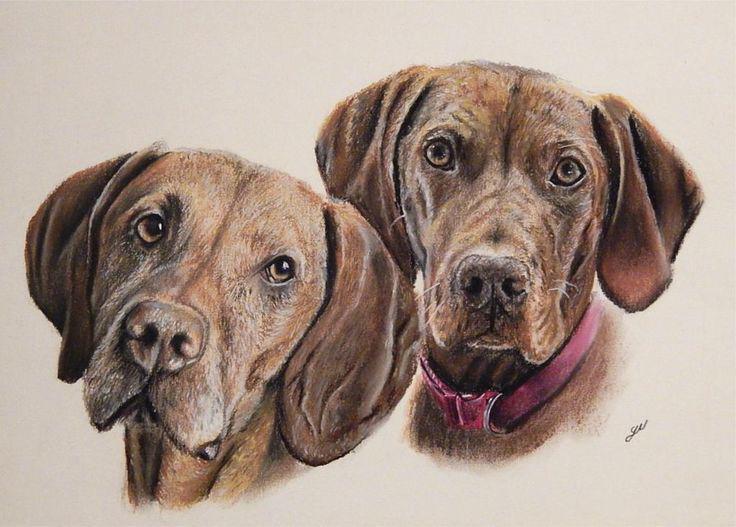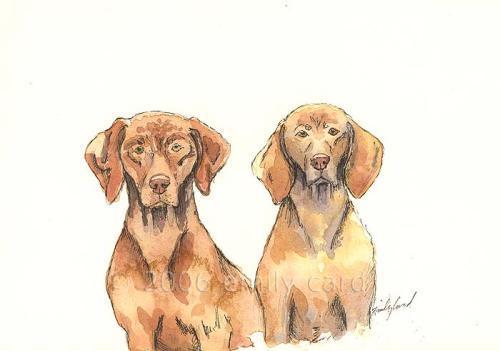The first image is the image on the left, the second image is the image on the right. Assess this claim about the two images: "The left and right image contains the same number of dogs.". Correct or not? Answer yes or no. Yes. The first image is the image on the left, the second image is the image on the right. Assess this claim about the two images: "The left image shows two leftward-facing red-orange dogs, and at least one of them is sitting upright.". Correct or not? Answer yes or no. No. 